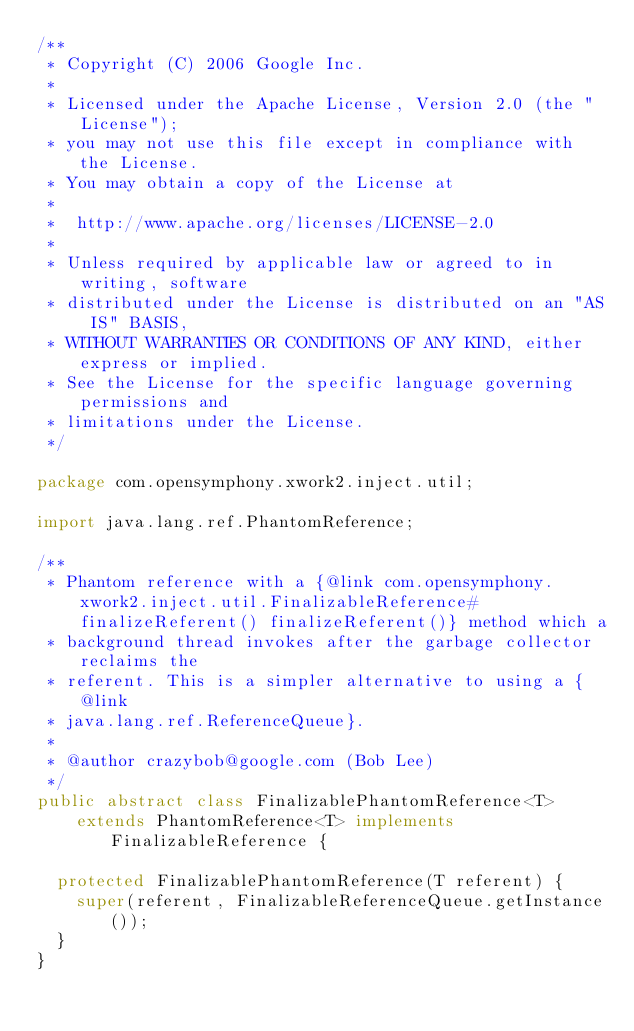<code> <loc_0><loc_0><loc_500><loc_500><_Java_>/**
 * Copyright (C) 2006 Google Inc.
 *
 * Licensed under the Apache License, Version 2.0 (the "License");
 * you may not use this file except in compliance with the License.
 * You may obtain a copy of the License at
 *
 *  http://www.apache.org/licenses/LICENSE-2.0
 *
 * Unless required by applicable law or agreed to in writing, software
 * distributed under the License is distributed on an "AS IS" BASIS,
 * WITHOUT WARRANTIES OR CONDITIONS OF ANY KIND, either express or implied.
 * See the License for the specific language governing permissions and
 * limitations under the License.
 */

package com.opensymphony.xwork2.inject.util;

import java.lang.ref.PhantomReference;

/**
 * Phantom reference with a {@link com.opensymphony.xwork2.inject.util.FinalizableReference#finalizeReferent() finalizeReferent()} method which a
 * background thread invokes after the garbage collector reclaims the
 * referent. This is a simpler alternative to using a {@link
 * java.lang.ref.ReferenceQueue}.
 *
 * @author crazybob@google.com (Bob Lee)
 */
public abstract class FinalizablePhantomReference<T>
    extends PhantomReference<T> implements FinalizableReference {

  protected FinalizablePhantomReference(T referent) {
    super(referent, FinalizableReferenceQueue.getInstance());
  }
}
</code> 